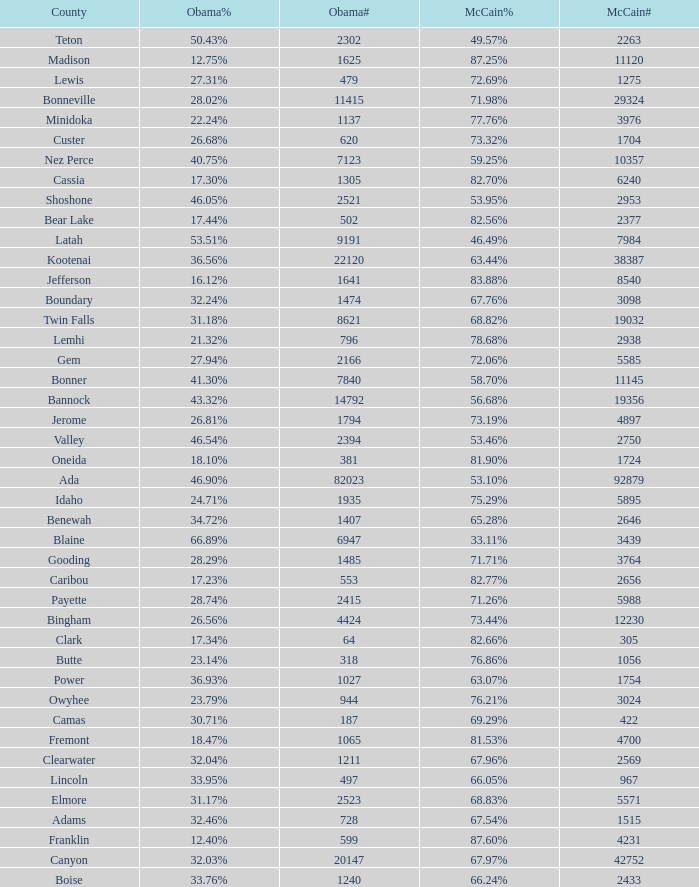What is the maximum McCain population turnout number? 92879.0. 